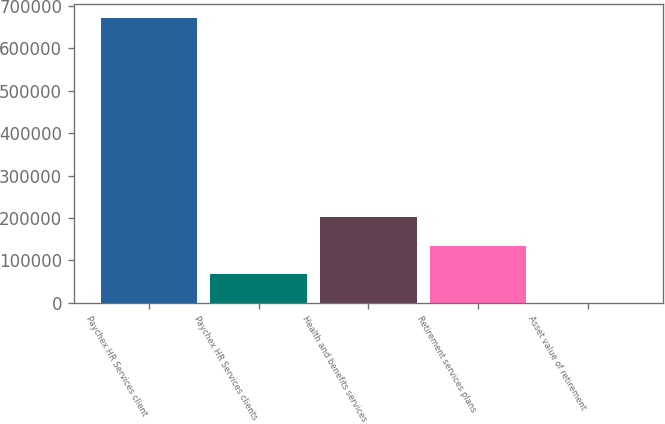<chart> <loc_0><loc_0><loc_500><loc_500><bar_chart><fcel>Paychex HR Services client<fcel>Paychex HR Services clients<fcel>Health and benefits services<fcel>Retirement services plans<fcel>Asset value of retirement<nl><fcel>672000<fcel>67217.4<fcel>201614<fcel>134415<fcel>19.3<nl></chart> 